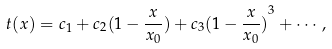Convert formula to latex. <formula><loc_0><loc_0><loc_500><loc_500>t ( x ) = c _ { 1 } + c _ { 2 } ( 1 - \frac { x } { x _ { 0 } } ) + c _ { 3 } { ( 1 - \frac { x } { x _ { 0 } } ) } ^ { 3 } + \cdots ,</formula> 